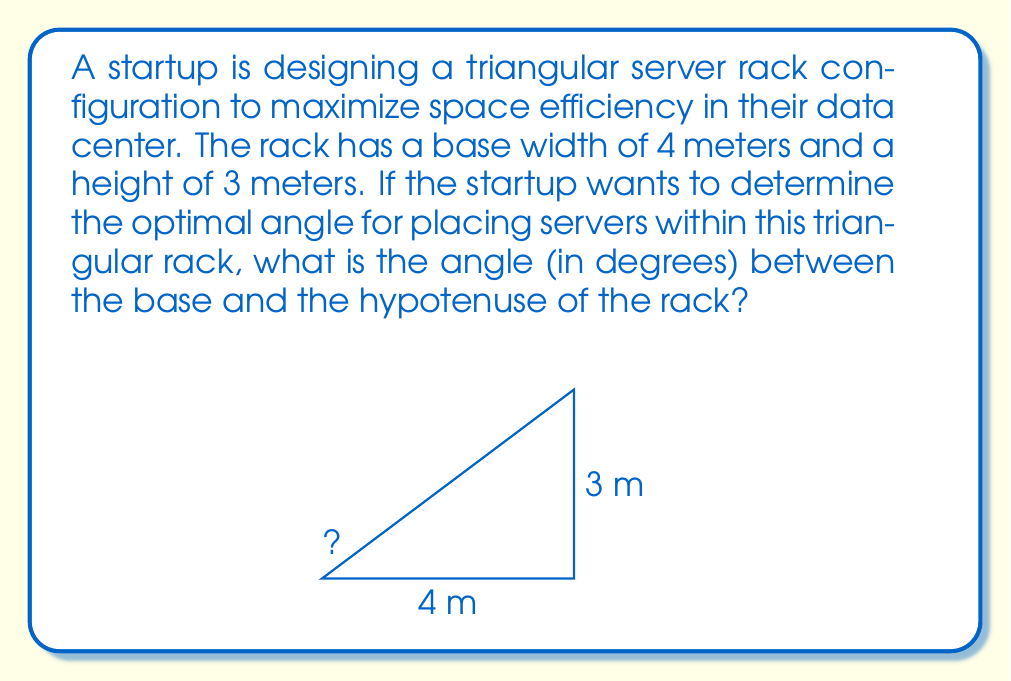Could you help me with this problem? To solve this problem, we need to use trigonometric functions, specifically the inverse tangent (arctan) function. Here's the step-by-step solution:

1. We have a right-angled triangle with the following known dimensions:
   - Base (adjacent side) = 4 meters
   - Height (opposite side) = 3 meters

2. We need to find the angle between the base and the hypotenuse. This angle can be calculated using the tangent function.

3. The tangent of an angle is defined as the ratio of the opposite side to the adjacent side:
   
   $$\tan(\theta) = \frac{\text{opposite}}{\text{adjacent}} = \frac{\text{height}}{\text{base}}$$

4. Substituting our values:

   $$\tan(\theta) = \frac{3}{4}$$

5. To find the angle, we need to use the inverse tangent (arctan or $\tan^{-1}$) function:

   $$\theta = \tan^{-1}\left(\frac{3}{4}\right)$$

6. Using a calculator or programming function to evaluate this:

   $$\theta \approx 36.87\text{°}$$

7. Rounding to two decimal places:

   $$\theta \approx 36.87\text{°}$$

This angle represents the optimal angle for placing servers within the triangular rack to maximize space efficiency.
Answer: $36.87\text{°}$ 